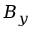<formula> <loc_0><loc_0><loc_500><loc_500>B _ { y }</formula> 